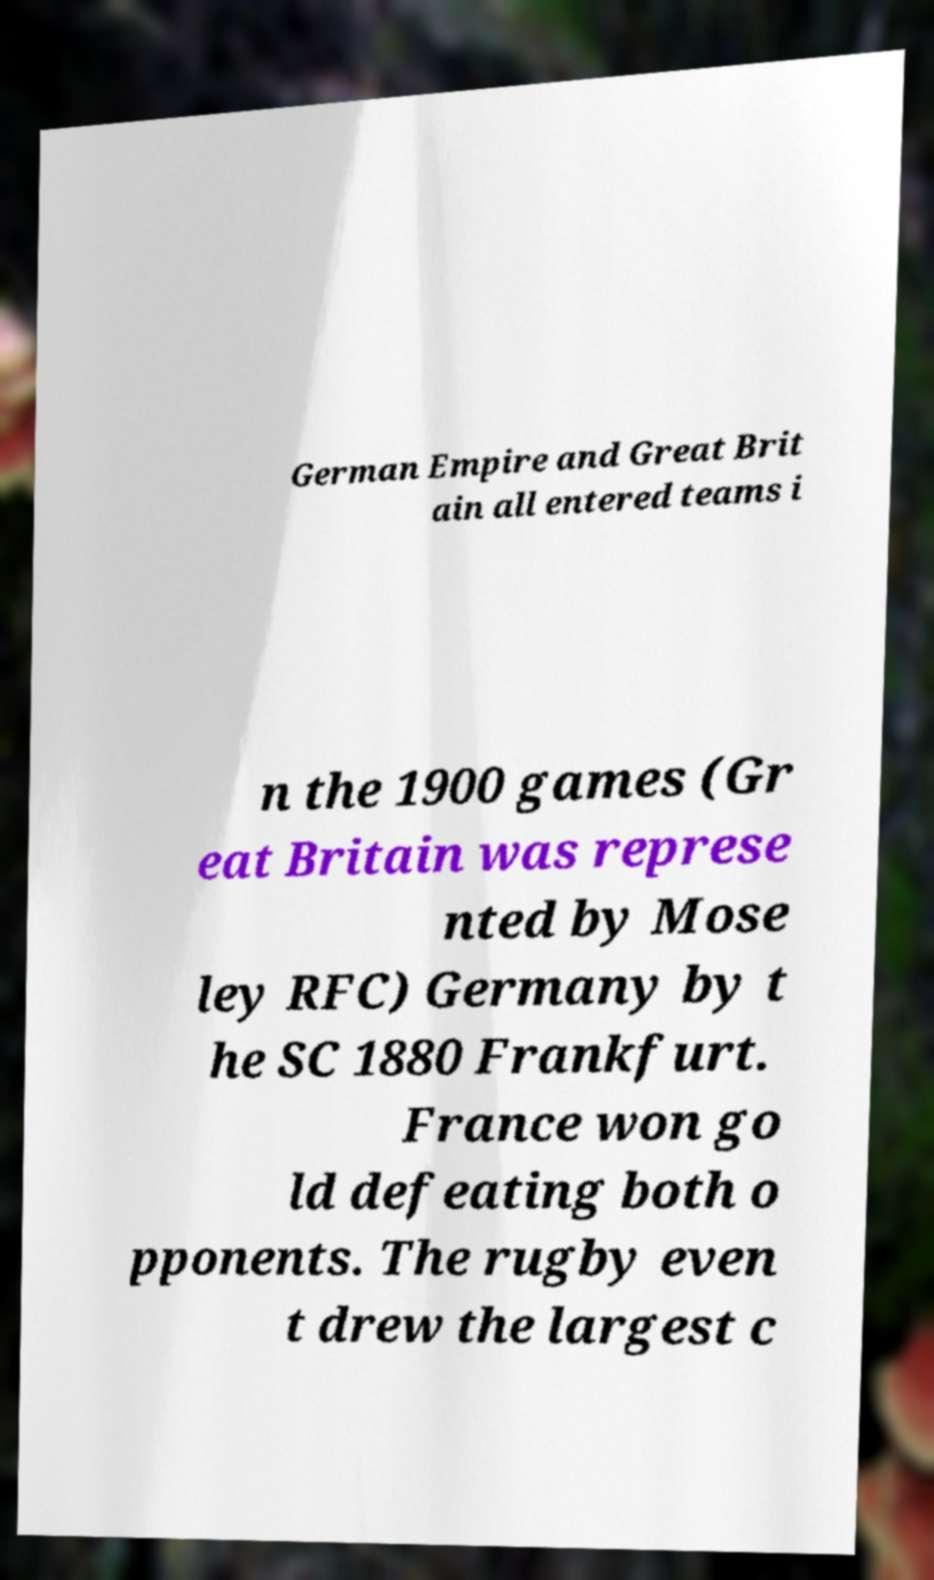What messages or text are displayed in this image? I need them in a readable, typed format. German Empire and Great Brit ain all entered teams i n the 1900 games (Gr eat Britain was represe nted by Mose ley RFC) Germany by t he SC 1880 Frankfurt. France won go ld defeating both o pponents. The rugby even t drew the largest c 